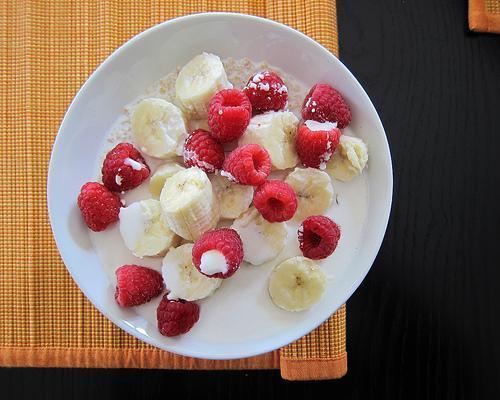How many people can be seen in the photo?
Give a very brief answer. 0. How many different fruit are in the bowl?
Give a very brief answer. 2. 